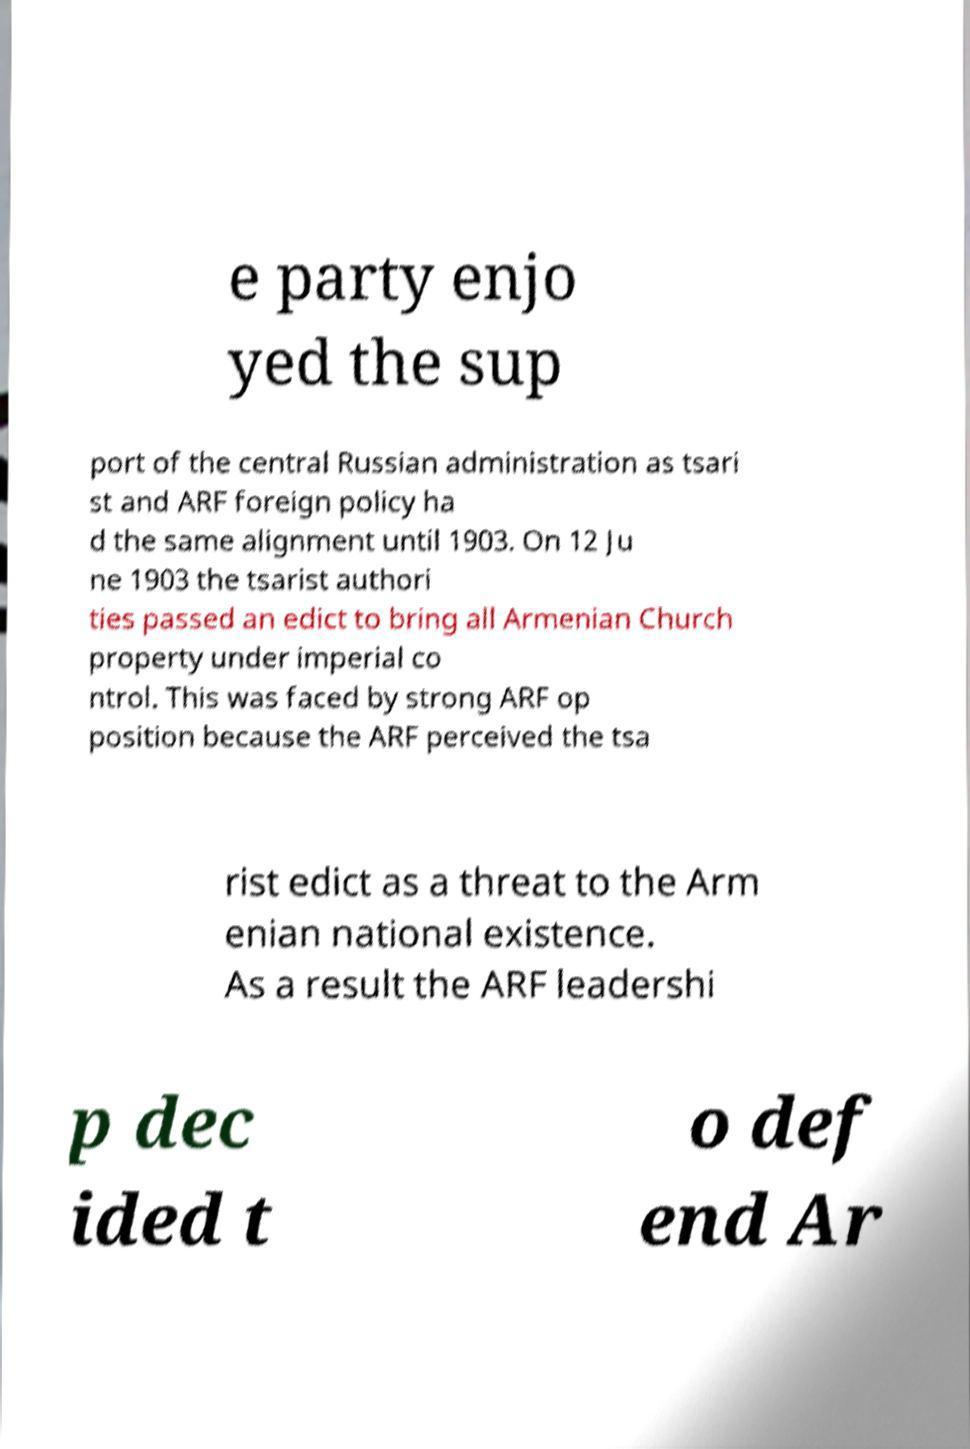I need the written content from this picture converted into text. Can you do that? e party enjo yed the sup port of the central Russian administration as tsari st and ARF foreign policy ha d the same alignment until 1903. On 12 Ju ne 1903 the tsarist authori ties passed an edict to bring all Armenian Church property under imperial co ntrol. This was faced by strong ARF op position because the ARF perceived the tsa rist edict as a threat to the Arm enian national existence. As a result the ARF leadershi p dec ided t o def end Ar 